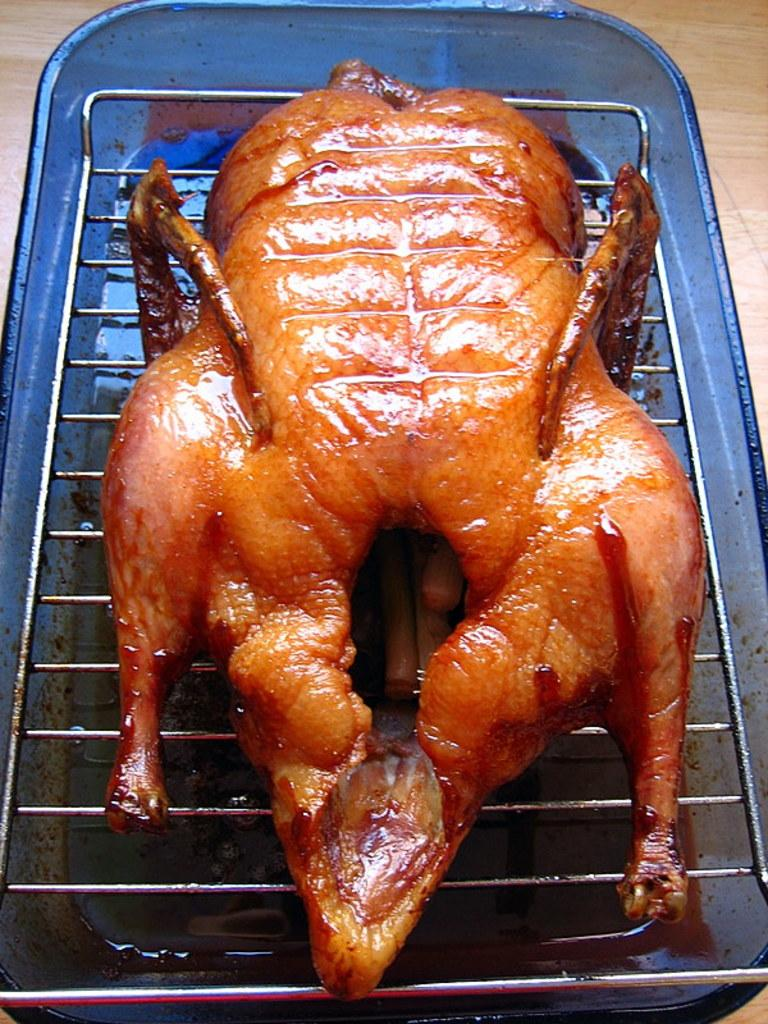What animal is present in the image? There is a chicken in the image. Where is the chicken located? The chicken is on a grill. What type of clover is growing around the chicken on the grill? There is no clover present in the image; it only features a chicken on a grill. 